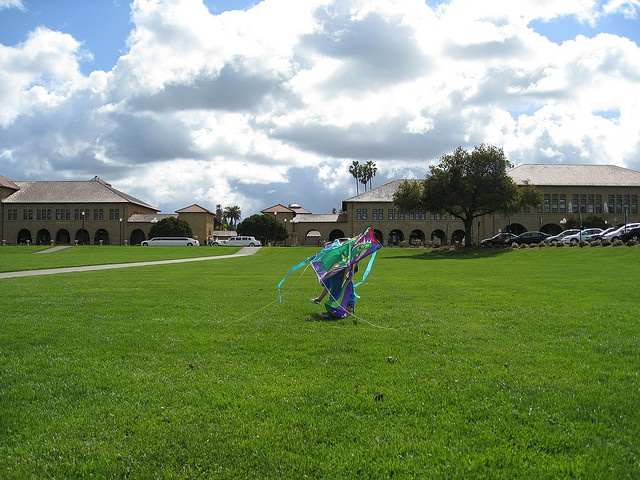Describe the objects in this image and their specific colors. I can see kite in lightblue, navy, teal, black, and green tones, people in lightblue, black, navy, darkgreen, and gray tones, car in lightblue, gray, darkgray, and black tones, car in lightblue, black, gray, purple, and darkgray tones, and car in lightblue, darkgray, gray, and black tones in this image. 